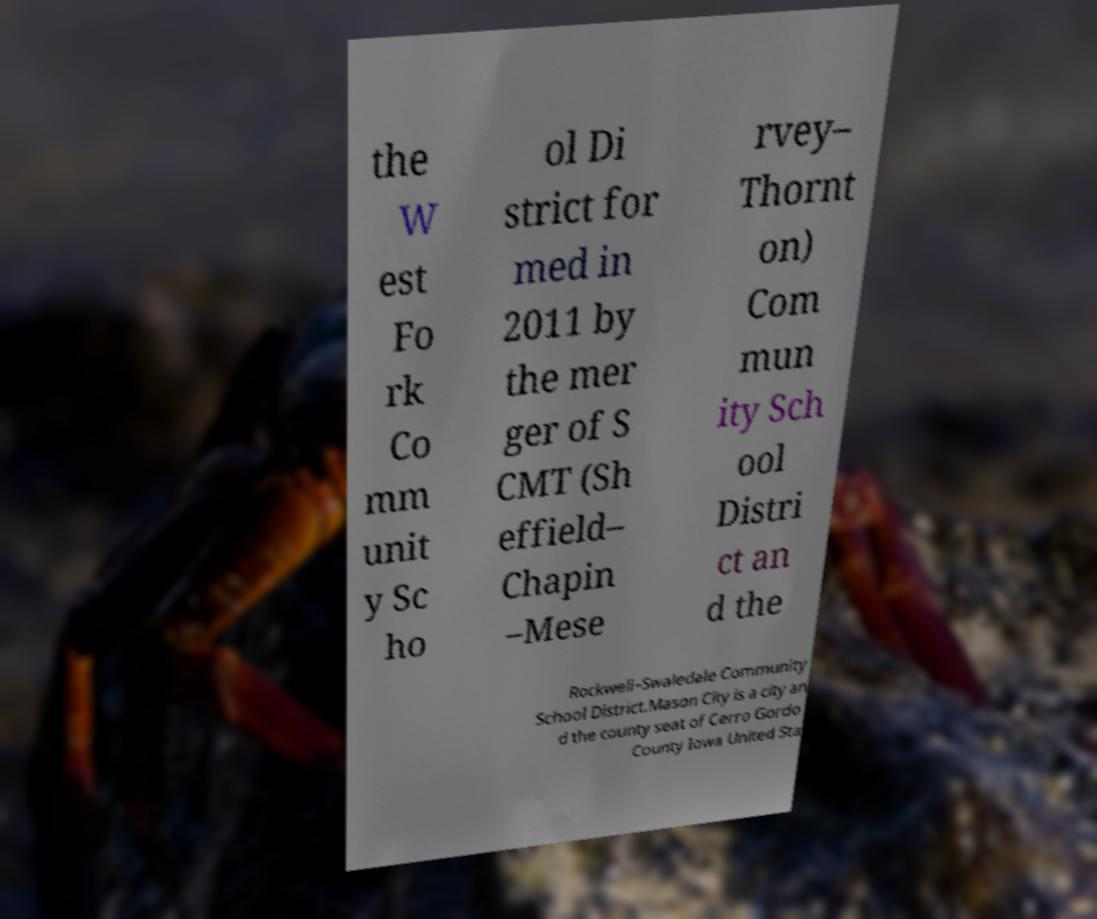I need the written content from this picture converted into text. Can you do that? the W est Fo rk Co mm unit y Sc ho ol Di strict for med in 2011 by the mer ger of S CMT (Sh effield– Chapin –Mese rvey– Thornt on) Com mun ity Sch ool Distri ct an d the Rockwell–Swaledale Community School District.Mason City is a city an d the county seat of Cerro Gordo County Iowa United Sta 